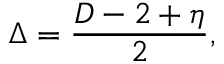<formula> <loc_0><loc_0><loc_500><loc_500>\Delta = { \frac { D - 2 + \eta } { 2 } } ,</formula> 